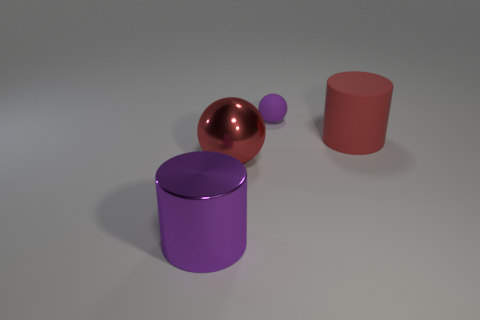There is a red rubber object; is it the same size as the cylinder that is in front of the red rubber object?
Ensure brevity in your answer.  Yes. Are there any other things that are the same shape as the red rubber object?
Provide a succinct answer. Yes. What number of big red shiny balls are there?
Provide a short and direct response. 1. How many cyan objects are big matte objects or large cylinders?
Offer a terse response. 0. Is the material of the purple thing to the right of the purple shiny cylinder the same as the big purple cylinder?
Your answer should be very brief. No. How many other objects are the same material as the red cylinder?
Your answer should be compact. 1. What material is the purple cylinder?
Your answer should be compact. Metal. There is a cylinder to the left of the small purple sphere; what is its size?
Provide a short and direct response. Large. How many metal cylinders are in front of the large cylinder left of the large metallic sphere?
Offer a terse response. 0. There is a purple thing right of the purple metallic cylinder; does it have the same shape as the large red thing left of the small matte thing?
Provide a short and direct response. Yes. 